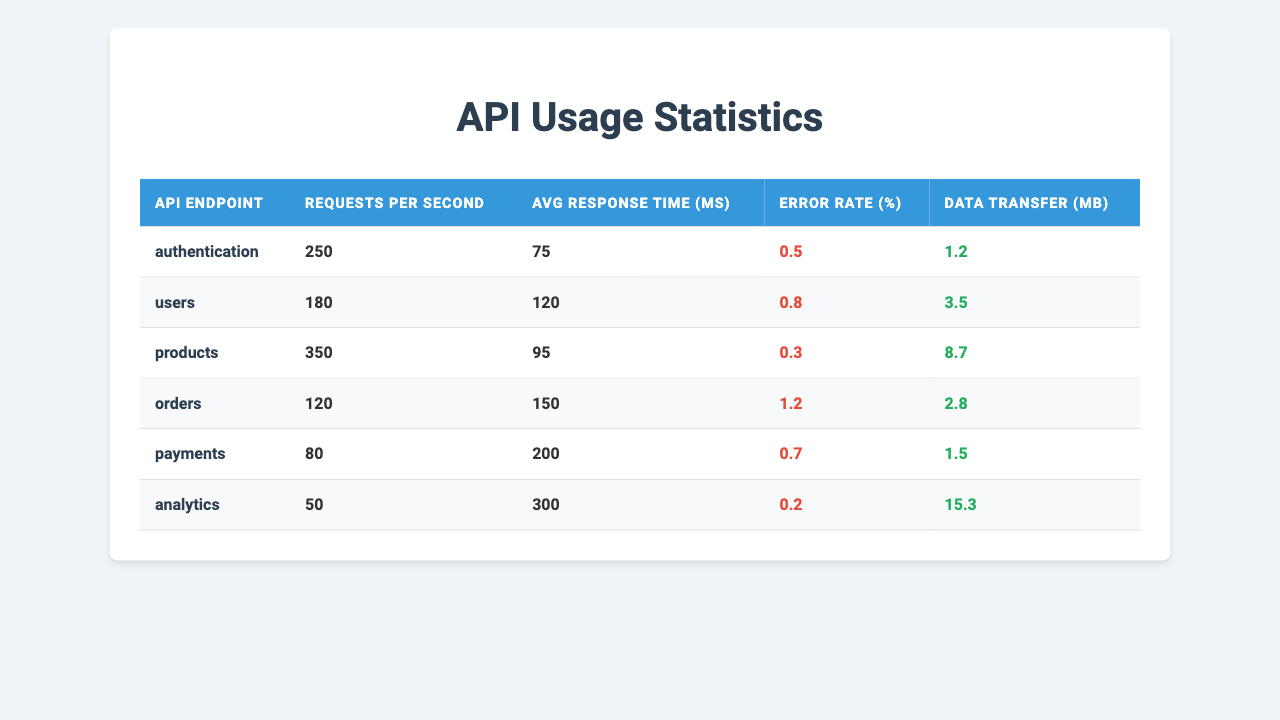What is the requests per second for the products endpoint? The table lists "350" under "Requests per Second" for the "products" endpoint.
Answer: 350 Which API endpoint has the highest average response time? The "analytics" endpoint has an average response time of "300 ms", which is the highest compared to others.
Answer: analytics What is the error rate percentage for the orders endpoint? The error rate percentage listed for the "orders" endpoint is "1.2%".
Answer: 1.2 Calculate the total requests per second across all endpoints. The total requests per second is the sum of each endpoint's requests: 250 + 180 + 350 + 120 + 80 + 50 = 1030.
Answer: 1030 Is the error rate for the users endpoint greater than 0.5%? Yes, the error rate for the "users" endpoint is "0.8%", which is greater than "0.5%".
Answer: Yes Which endpoint has the lowest data transfer in MB? The "authentication" endpoint has the lowest data transfer of "1.2 MB".
Answer: authentication What is the average response time for all endpoints combined? To find the average response time, sum all average response times (75 + 120 + 95 + 150 + 200 + 300) = 940 ms. There are 6 endpoints, so the average is 940 / 6 = 156.67.
Answer: 156.67 Which endpoint has the lowest requests per second, and what is that value? The "analytics" endpoint has the lowest requests per second with a value of "50".
Answer: analytics, 50 Determine if the error rate percentage for products is lower than the error rate for payments. The error rate for "products" is "0.3%", while for "payments" it is "0.7%", so "0.3% < 0.7%". This is true, hence the products endpoint has a lower error rate.
Answer: Yes What is the median average response time among all endpoints? Sorting the average response times gives: 75, 95, 120, 150, 200, 300. The median is the average of the 3rd (120) and 4th (150) values: (120 + 150) / 2 = 135.
Answer: 135 